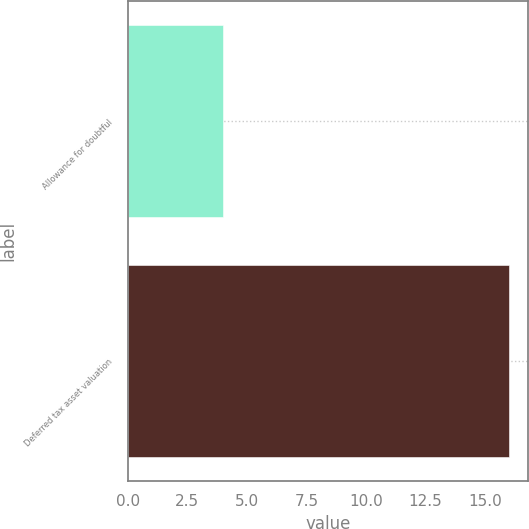Convert chart to OTSL. <chart><loc_0><loc_0><loc_500><loc_500><bar_chart><fcel>Allowance for doubtful<fcel>Deferred tax asset valuation<nl><fcel>4<fcel>16<nl></chart> 